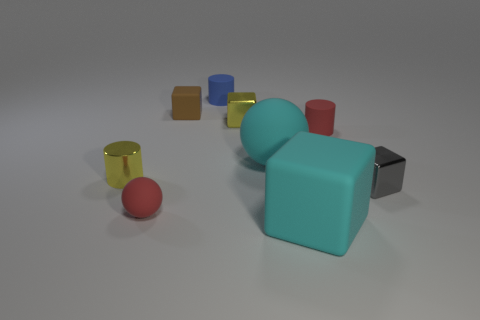Can you tell me the colors of all the objects in the scene? Certainly! There is a diversity of colors among the objects in the scene. The cylinders come in red and yellow, the cubes are blue, orange, aqua, and gray, and there's a red sphere as well. Are these colors primary, secondary, or tertiary? The red and blue colors are primary, the orange is a secondary color created by mixing red and yellow, and the aqua is a secondary color as well, resulting from a mixture of blue and green. The yellow cylinder also represents a primary color, while the gray cube can be seen as achromatic, lacking a distinctive hue. 